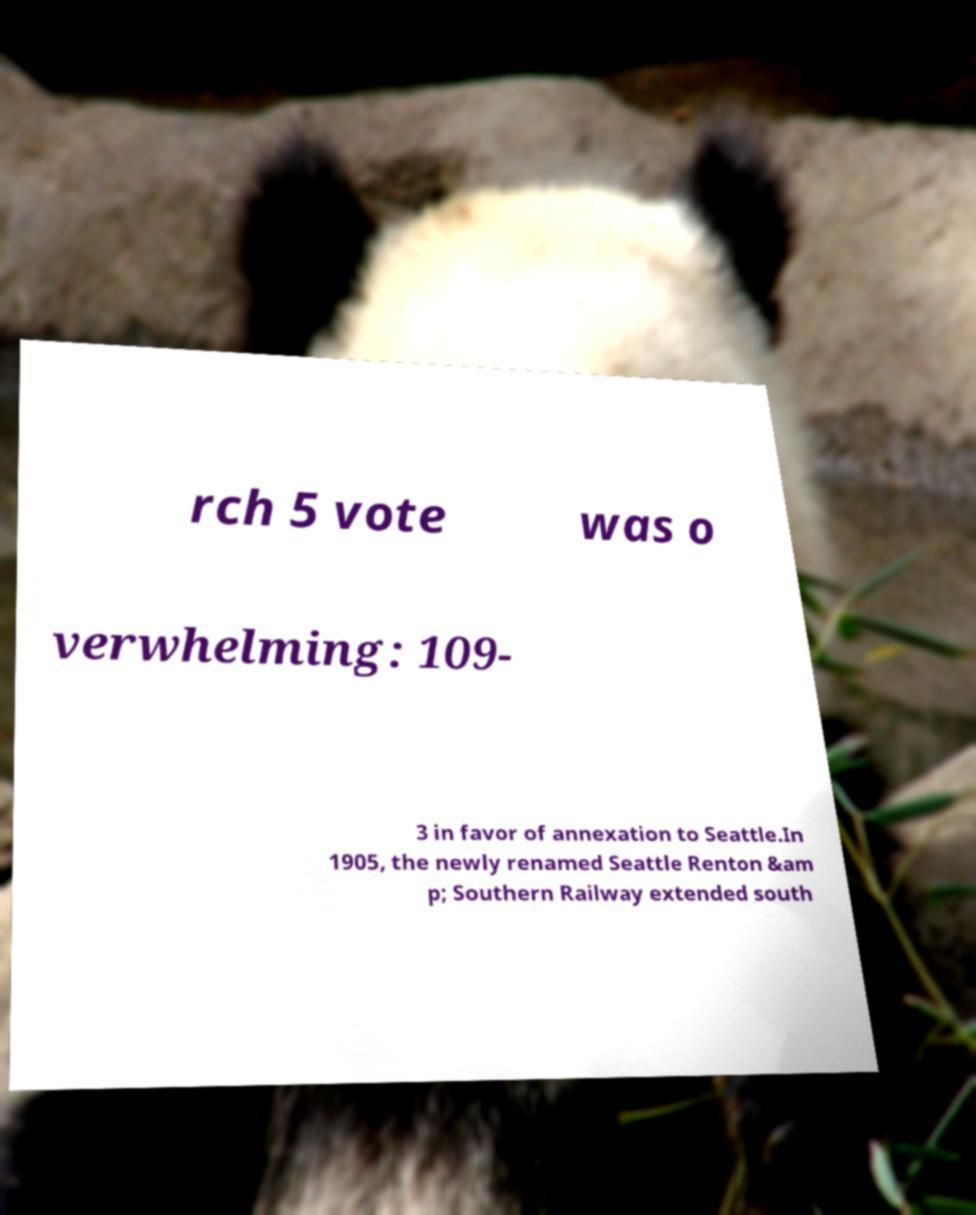Please read and relay the text visible in this image. What does it say? rch 5 vote was o verwhelming: 109- 3 in favor of annexation to Seattle.In 1905, the newly renamed Seattle Renton &am p; Southern Railway extended south 